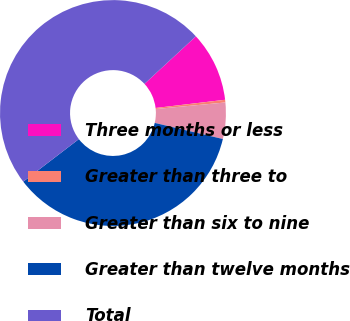Convert chart to OTSL. <chart><loc_0><loc_0><loc_500><loc_500><pie_chart><fcel>Three months or less<fcel>Greater than three to<fcel>Greater than six to nine<fcel>Greater than twelve months<fcel>Total<nl><fcel>10.01%<fcel>0.38%<fcel>5.19%<fcel>35.91%<fcel>48.51%<nl></chart> 